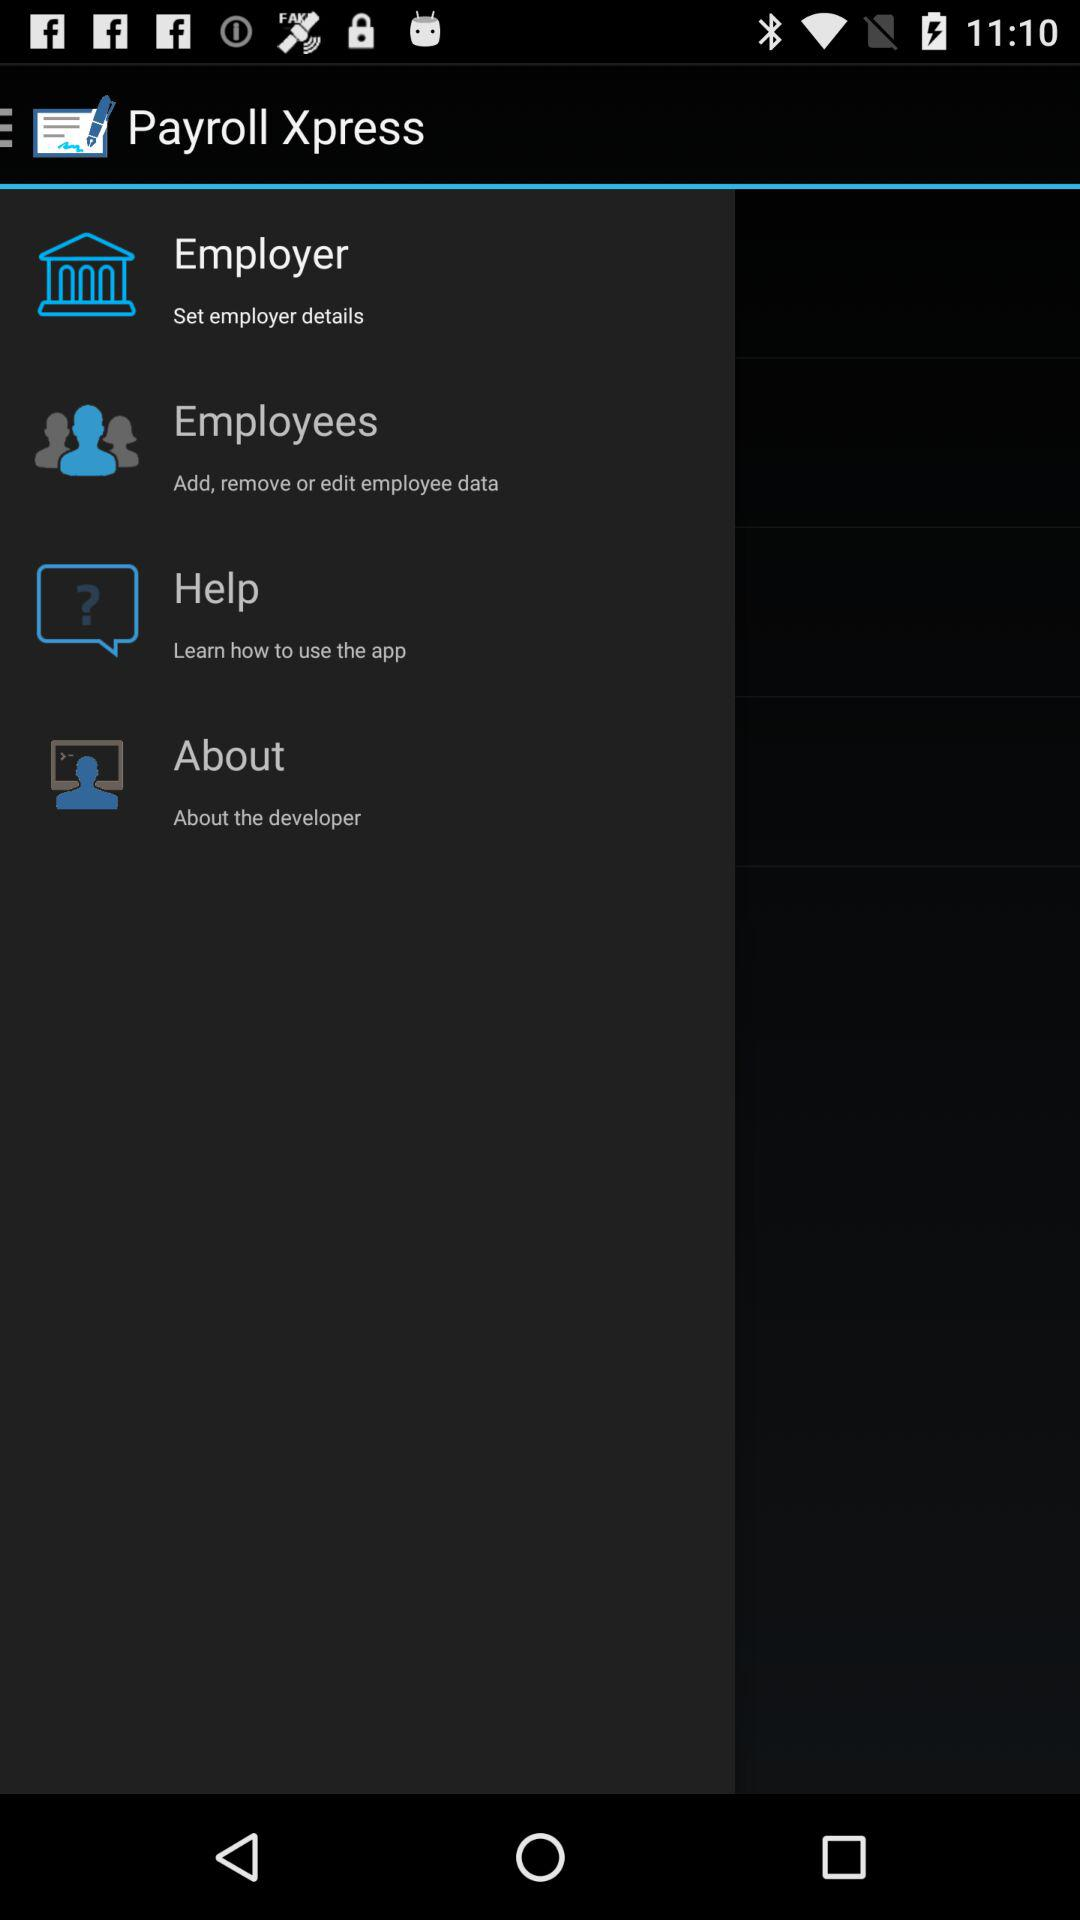How many items are in the main menu?
Answer the question using a single word or phrase. 4 